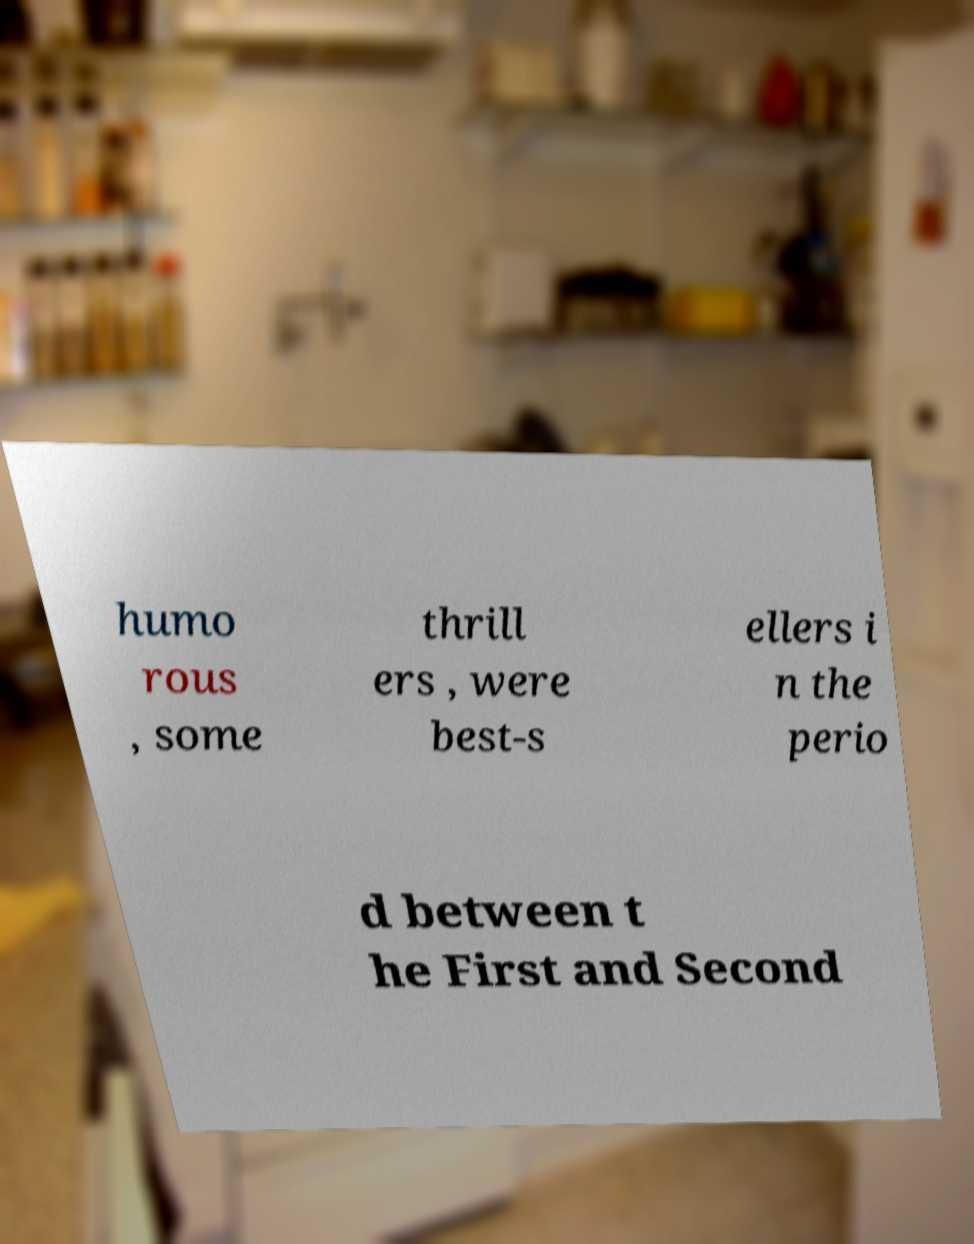Can you read and provide the text displayed in the image?This photo seems to have some interesting text. Can you extract and type it out for me? humo rous , some thrill ers , were best-s ellers i n the perio d between t he First and Second 